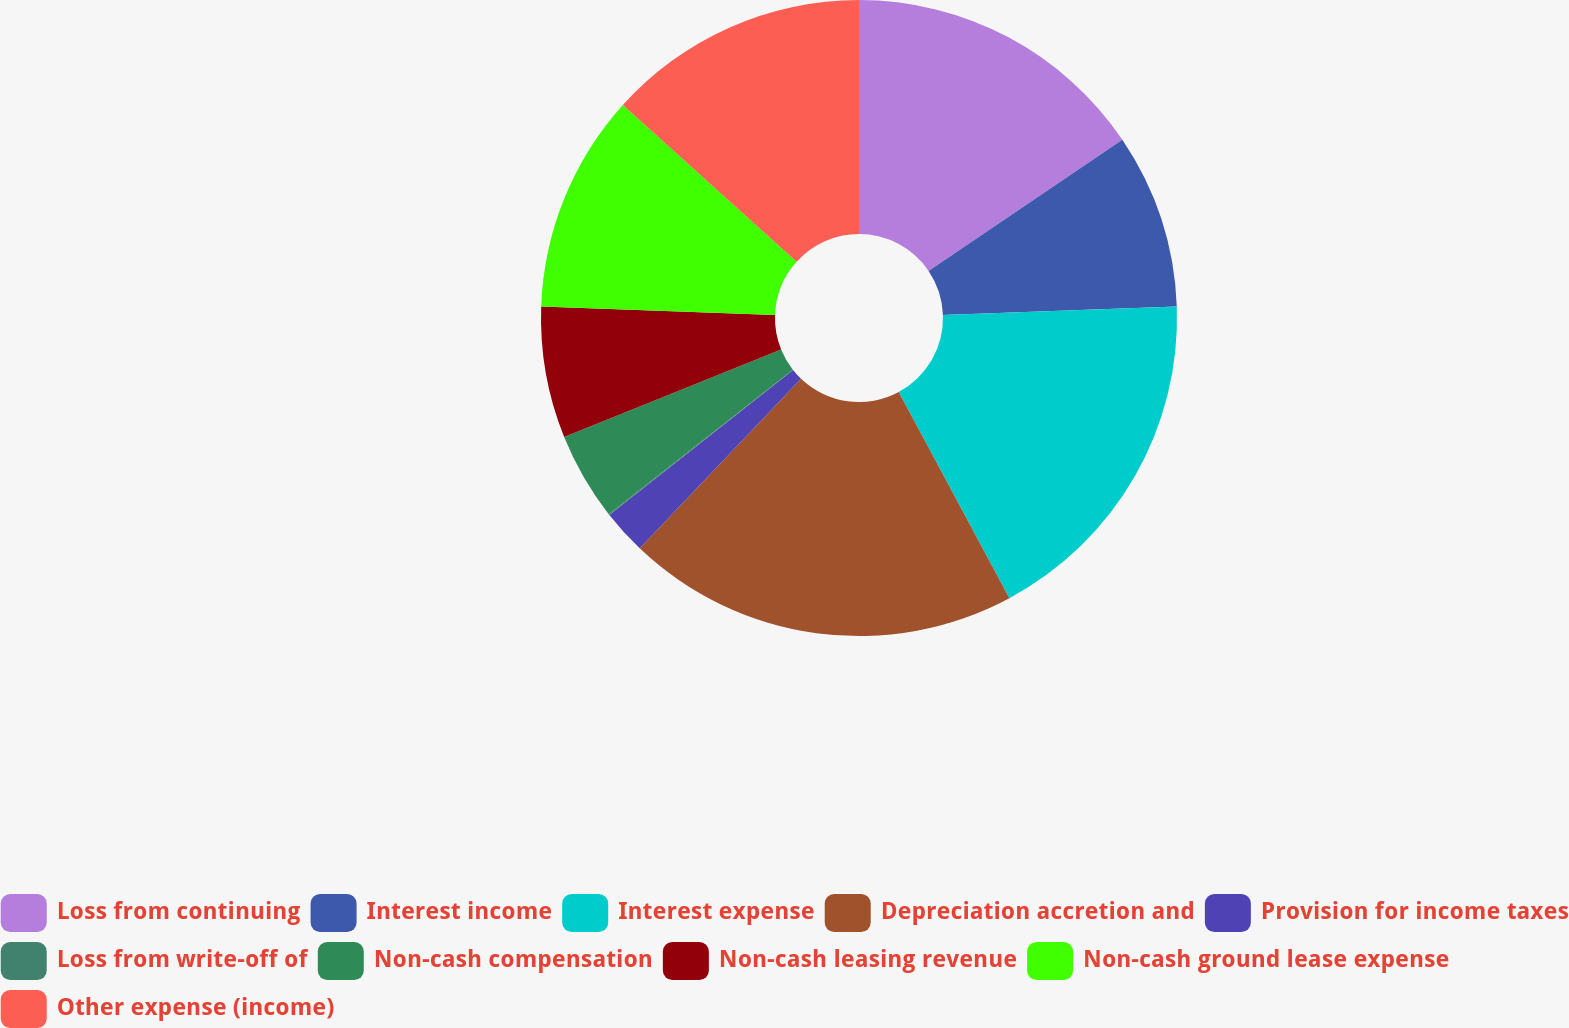Convert chart. <chart><loc_0><loc_0><loc_500><loc_500><pie_chart><fcel>Loss from continuing<fcel>Interest income<fcel>Interest expense<fcel>Depreciation accretion and<fcel>Provision for income taxes<fcel>Loss from write-off of<fcel>Non-cash compensation<fcel>Non-cash leasing revenue<fcel>Non-cash ground lease expense<fcel>Other expense (income)<nl><fcel>15.53%<fcel>8.89%<fcel>17.74%<fcel>19.95%<fcel>2.26%<fcel>0.05%<fcel>4.47%<fcel>6.68%<fcel>11.11%<fcel>13.32%<nl></chart> 